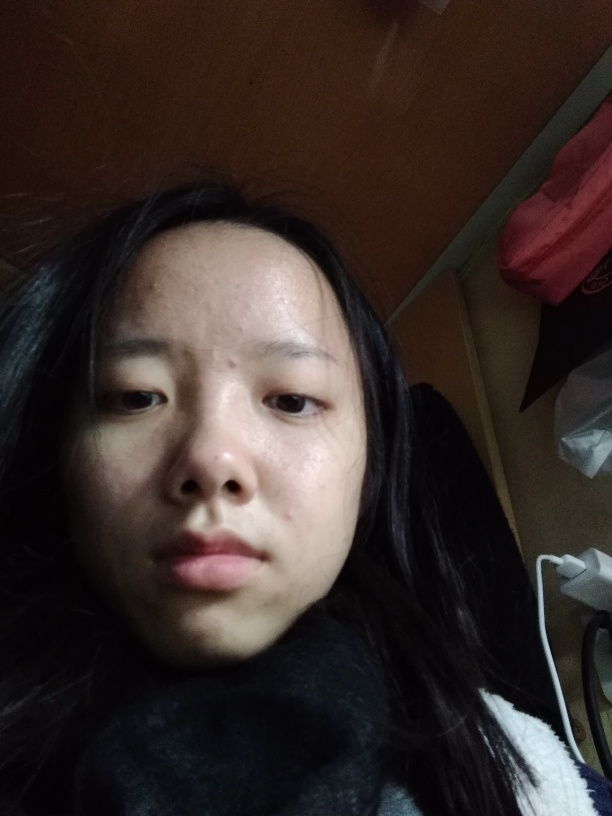Are there any focus issues with the image? The image seems very clear and lacks noticeable blur or softness, which suggests that focus has been achieved appropriately. All the prominent features of the subject's face, such as eyes, nose, lips, and skin texture, are sharp, allowing for detailed observation. Therefore, the correct answer would be A, indicating no issues with focus. 